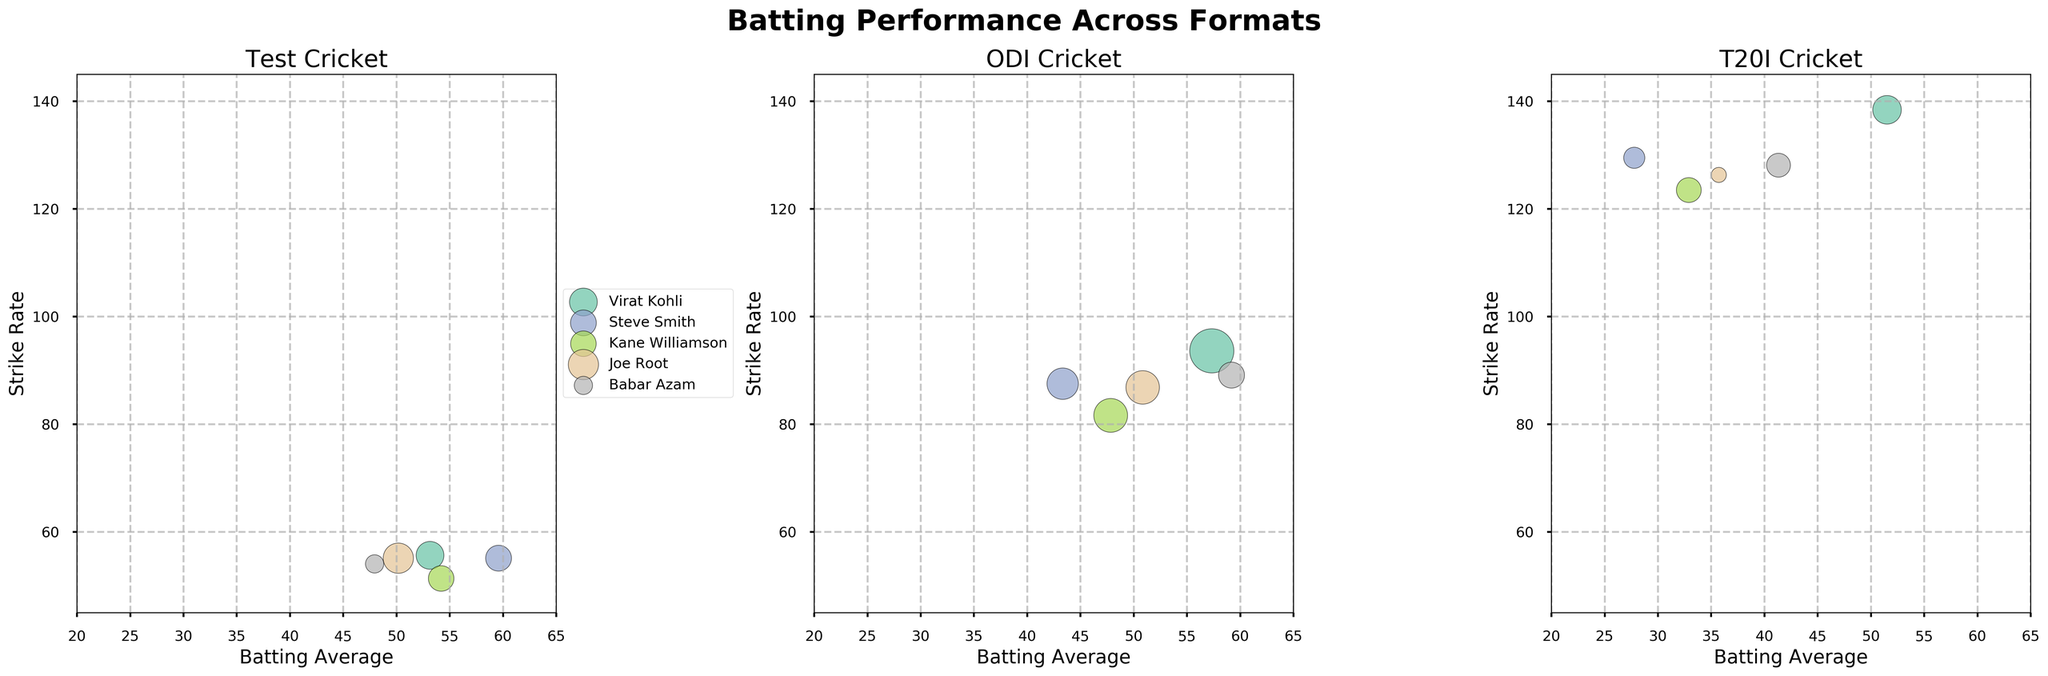What's the title of the figure? The title of the figure is located at the top center and reads "Batting Performance Across Formats."
Answer: Batting Performance Across Formats Which player has the highest batting average in Test cricket? In the Test cricket subplot, the player with the highest bubble along the Batting Average axis is Steve Smith with an average of 59.58.
Answer: Steve Smith Who has the highest strike rate in T20I cricket? In the T20I subplot, the player with the highest position along the Strike Rate axis is Virat Kohli with a strike rate of 138.43.
Answer: Virat Kohli How do the Test batting averages of Virat Kohli and Joe Root compare? In the Test cricket subplot, Virat Kohli has a batting average of 53.13, while Joe Root has a batting average of 50.17, making Kohli's average slightly higher.
Answer: Virat Kohli has a higher average than Joe Root Which format shows the highest bubble size for Babar Azam? The size of the bubble indicates the number of matches played. In the ODI subplot, Babar Azam has the largest bubble, representing 95 matches.
Answer: ODI Is there any player who has a higher batting average in T20I than in Tests? By comparing the Test and T20I subplots, no player has a higher batting average in T20I. All players have lower or similar averages in T20I compared to their Test averages.
Answer: No Which player has the least strike rate in ODI cricket? In the ODI subplot, the player with the lowest position along the Strike Rate axis is Kane Williamson with a strike rate of 81.65.
Answer: Kane Williamson How does the strike rate of Steve Smith in T20Is compare to his strike rate in Tests? In the Test cricket subplot, Steve Smith has a strike rate of 55.11. In the T20I subplot, his strike rate is 129.52, which means his T20I strike rate is significantly higher.
Answer: Higher in T20I Which player has the most balanced performance across all three formats in terms of batting average and strike rate? By observing all three subplots, Virat Kohli has a high and consistent batting average and strike rate across Tests, ODIs, and T20Is, suggesting balanced performance.
Answer: Virat Kohli Compare the strike rates of Babar Azam and Kane Williamson in ODIs. In the ODI subplot, Babar Azam's strike rate is 89.14, while Kane Williamson's strike rate is 81.65. Babar Azam has a higher strike rate.
Answer: Babar Azam 